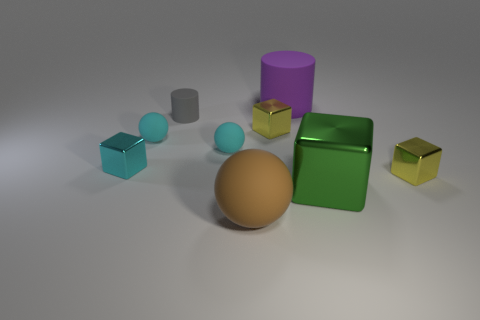How does the lighting affect the appearance of the colors in this image? The lighting in this image casts soft shadows and enhances the vibrancy of the colors. It creates highlights on the surfaces of the objects, giving them a three-dimensional appearance and emphasizing the differences in their materials. 